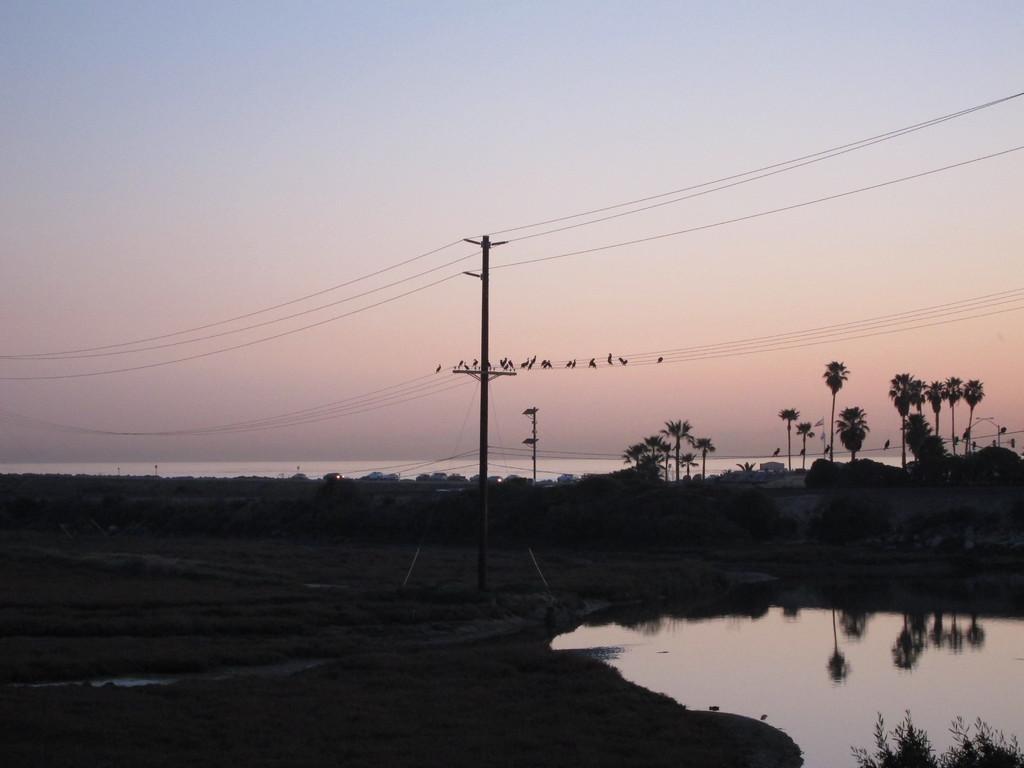In one or two sentences, can you explain what this image depicts? In this picture we can see there are trees, water and electric poles with cables and there are birds on the cables. Behind the trees there is the sky. 